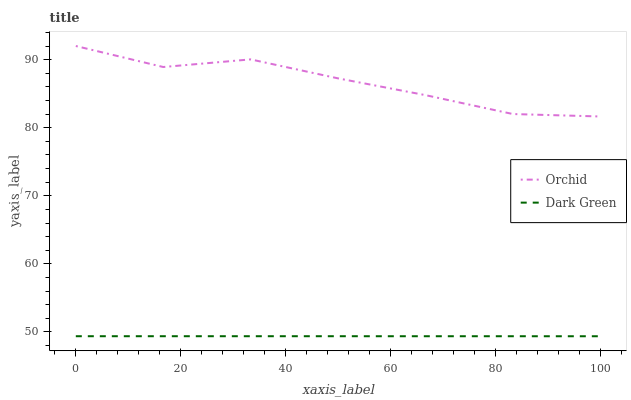Does Dark Green have the minimum area under the curve?
Answer yes or no. Yes. Does Orchid have the maximum area under the curve?
Answer yes or no. Yes. Does Orchid have the minimum area under the curve?
Answer yes or no. No. Is Dark Green the smoothest?
Answer yes or no. Yes. Is Orchid the roughest?
Answer yes or no. Yes. Is Orchid the smoothest?
Answer yes or no. No. Does Dark Green have the lowest value?
Answer yes or no. Yes. Does Orchid have the lowest value?
Answer yes or no. No. Does Orchid have the highest value?
Answer yes or no. Yes. Is Dark Green less than Orchid?
Answer yes or no. Yes. Is Orchid greater than Dark Green?
Answer yes or no. Yes. Does Dark Green intersect Orchid?
Answer yes or no. No. 